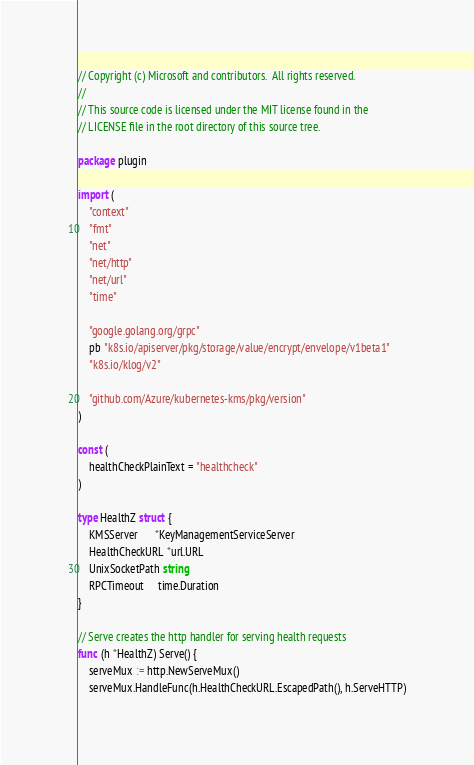Convert code to text. <code><loc_0><loc_0><loc_500><loc_500><_Go_>// Copyright (c) Microsoft and contributors.  All rights reserved.
//
// This source code is licensed under the MIT license found in the
// LICENSE file in the root directory of this source tree.

package plugin

import (
	"context"
	"fmt"
	"net"
	"net/http"
	"net/url"
	"time"

	"google.golang.org/grpc"
	pb "k8s.io/apiserver/pkg/storage/value/encrypt/envelope/v1beta1"
	"k8s.io/klog/v2"

	"github.com/Azure/kubernetes-kms/pkg/version"
)

const (
	healthCheckPlainText = "healthcheck"
)

type HealthZ struct {
	KMSServer      *KeyManagementServiceServer
	HealthCheckURL *url.URL
	UnixSocketPath string
	RPCTimeout     time.Duration
}

// Serve creates the http handler for serving health requests
func (h *HealthZ) Serve() {
	serveMux := http.NewServeMux()
	serveMux.HandleFunc(h.HealthCheckURL.EscapedPath(), h.ServeHTTP)</code> 